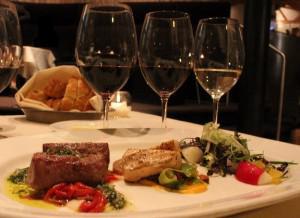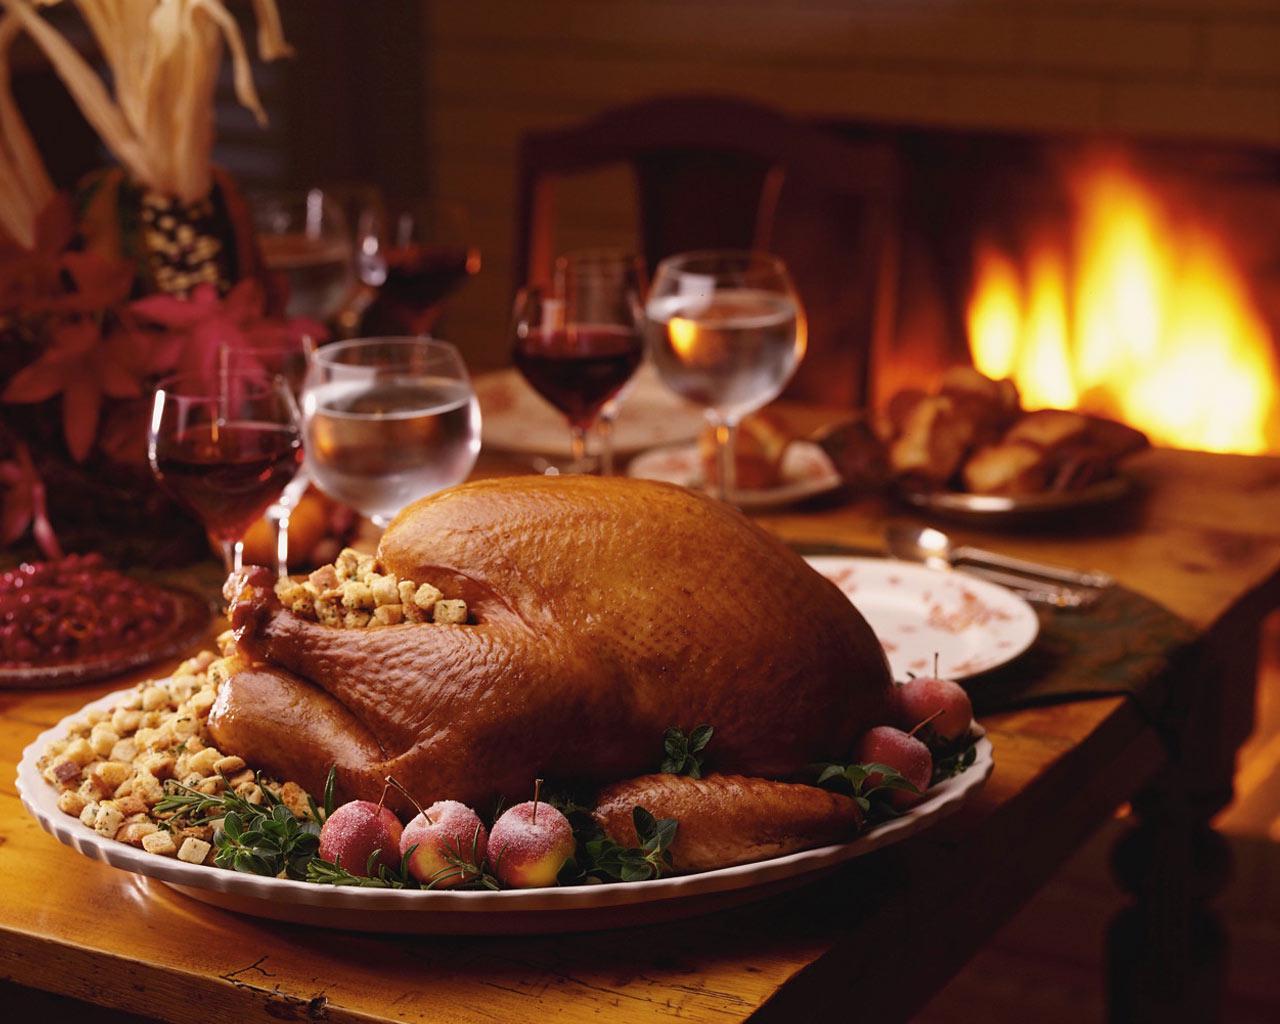The first image is the image on the left, the second image is the image on the right. For the images shown, is this caption "The table in the image on the left has a white table cloth." true? Answer yes or no. Yes. The first image is the image on the left, the second image is the image on the right. Evaluate the accuracy of this statement regarding the images: "Left image shows a table holding exactly two glasses, which contain dark wine.". Is it true? Answer yes or no. No. 